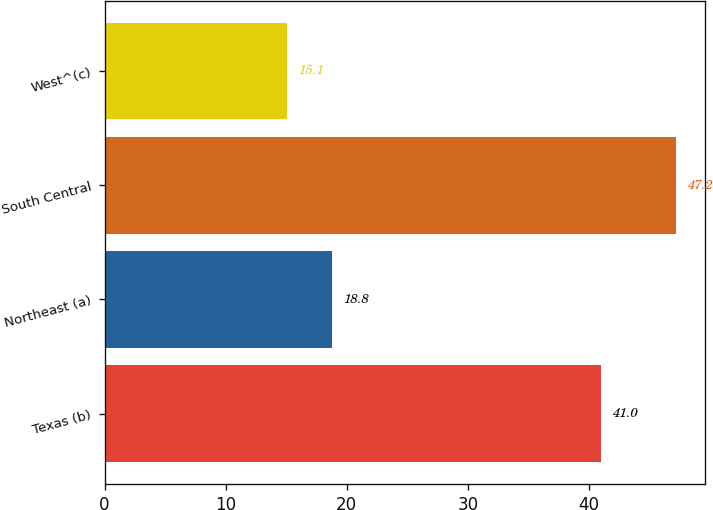Convert chart. <chart><loc_0><loc_0><loc_500><loc_500><bar_chart><fcel>Texas (b)<fcel>Northeast (a)<fcel>South Central<fcel>West^(c)<nl><fcel>41<fcel>18.8<fcel>47.2<fcel>15.1<nl></chart> 